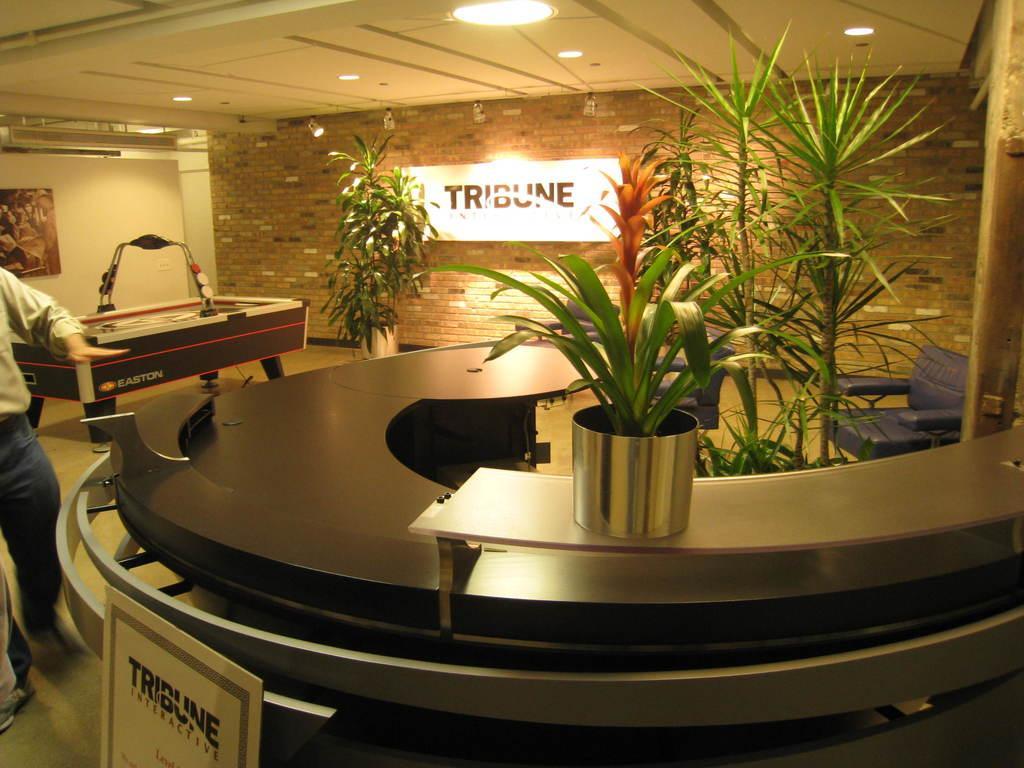Please provide a concise description of this image. This picture shows a man walking and we see few plants and we see a chair and couple of roof lights 